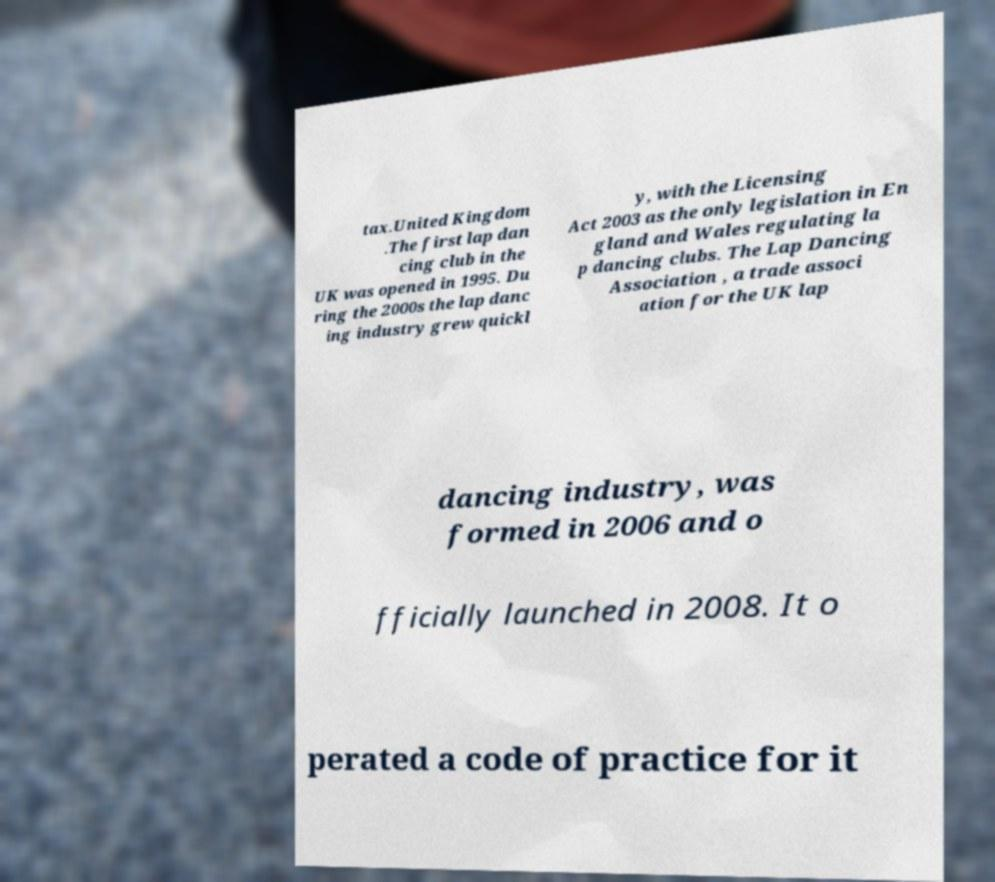There's text embedded in this image that I need extracted. Can you transcribe it verbatim? tax.United Kingdom .The first lap dan cing club in the UK was opened in 1995. Du ring the 2000s the lap danc ing industry grew quickl y, with the Licensing Act 2003 as the only legislation in En gland and Wales regulating la p dancing clubs. The Lap Dancing Association , a trade associ ation for the UK lap dancing industry, was formed in 2006 and o fficially launched in 2008. It o perated a code of practice for it 